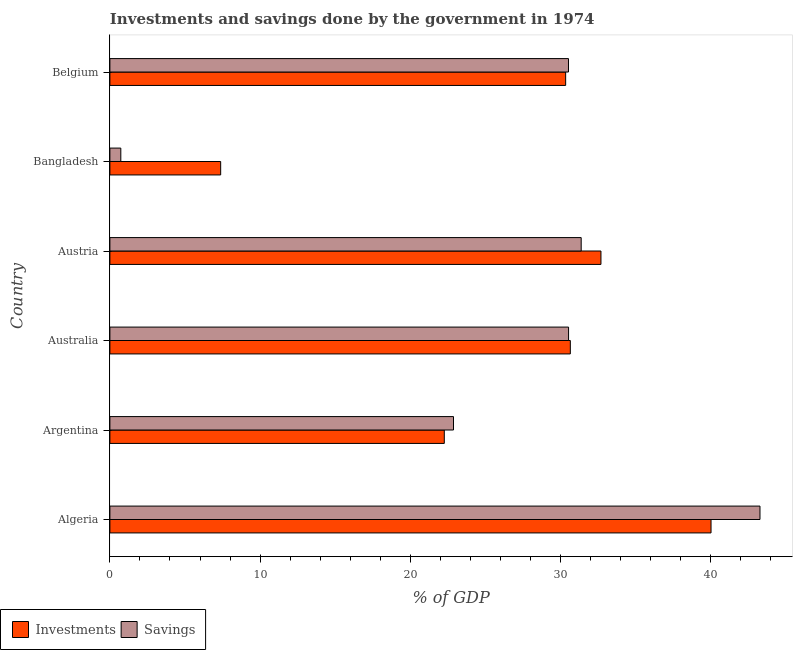How many different coloured bars are there?
Your response must be concise. 2. Are the number of bars on each tick of the Y-axis equal?
Make the answer very short. Yes. How many bars are there on the 3rd tick from the top?
Your answer should be compact. 2. How many bars are there on the 5th tick from the bottom?
Your answer should be very brief. 2. What is the label of the 2nd group of bars from the top?
Provide a short and direct response. Bangladesh. In how many cases, is the number of bars for a given country not equal to the number of legend labels?
Provide a succinct answer. 0. What is the investments of government in Australia?
Your answer should be very brief. 30.65. Across all countries, what is the maximum investments of government?
Your response must be concise. 40.02. Across all countries, what is the minimum investments of government?
Ensure brevity in your answer.  7.37. In which country was the savings of government maximum?
Keep it short and to the point. Algeria. In which country was the investments of government minimum?
Keep it short and to the point. Bangladesh. What is the total investments of government in the graph?
Your answer should be compact. 163.33. What is the difference between the savings of government in Austria and that in Bangladesh?
Provide a succinct answer. 30.65. What is the difference between the investments of government in Australia and the savings of government in Austria?
Offer a terse response. -0.72. What is the average investments of government per country?
Give a very brief answer. 27.22. What is the difference between the investments of government and savings of government in Argentina?
Make the answer very short. -0.61. What is the ratio of the savings of government in Algeria to that in Australia?
Your answer should be very brief. 1.42. What is the difference between the highest and the second highest savings of government?
Ensure brevity in your answer.  11.9. What is the difference between the highest and the lowest savings of government?
Offer a terse response. 42.55. Is the sum of the savings of government in Australia and Belgium greater than the maximum investments of government across all countries?
Offer a very short reply. Yes. What does the 2nd bar from the top in Argentina represents?
Ensure brevity in your answer.  Investments. What does the 2nd bar from the bottom in Australia represents?
Make the answer very short. Savings. Are the values on the major ticks of X-axis written in scientific E-notation?
Your answer should be very brief. No. Where does the legend appear in the graph?
Your answer should be compact. Bottom left. How are the legend labels stacked?
Offer a terse response. Horizontal. What is the title of the graph?
Make the answer very short. Investments and savings done by the government in 1974. Does "Nitrous oxide" appear as one of the legend labels in the graph?
Make the answer very short. No. What is the label or title of the X-axis?
Your response must be concise. % of GDP. What is the % of GDP in Investments in Algeria?
Provide a short and direct response. 40.02. What is the % of GDP in Savings in Algeria?
Provide a succinct answer. 43.28. What is the % of GDP in Investments in Argentina?
Give a very brief answer. 22.26. What is the % of GDP of Savings in Argentina?
Provide a succinct answer. 22.87. What is the % of GDP in Investments in Australia?
Offer a terse response. 30.65. What is the % of GDP of Savings in Australia?
Your answer should be compact. 30.53. What is the % of GDP of Investments in Austria?
Offer a terse response. 32.69. What is the % of GDP of Savings in Austria?
Your answer should be compact. 31.37. What is the % of GDP in Investments in Bangladesh?
Offer a very short reply. 7.37. What is the % of GDP in Savings in Bangladesh?
Make the answer very short. 0.73. What is the % of GDP of Investments in Belgium?
Provide a succinct answer. 30.34. What is the % of GDP of Savings in Belgium?
Offer a very short reply. 30.53. Across all countries, what is the maximum % of GDP in Investments?
Give a very brief answer. 40.02. Across all countries, what is the maximum % of GDP of Savings?
Offer a terse response. 43.28. Across all countries, what is the minimum % of GDP in Investments?
Keep it short and to the point. 7.37. Across all countries, what is the minimum % of GDP of Savings?
Make the answer very short. 0.73. What is the total % of GDP of Investments in the graph?
Ensure brevity in your answer.  163.33. What is the total % of GDP of Savings in the graph?
Make the answer very short. 159.31. What is the difference between the % of GDP in Investments in Algeria and that in Argentina?
Give a very brief answer. 17.76. What is the difference between the % of GDP in Savings in Algeria and that in Argentina?
Make the answer very short. 20.4. What is the difference between the % of GDP of Investments in Algeria and that in Australia?
Provide a succinct answer. 9.37. What is the difference between the % of GDP of Savings in Algeria and that in Australia?
Provide a succinct answer. 12.74. What is the difference between the % of GDP of Investments in Algeria and that in Austria?
Offer a terse response. 7.33. What is the difference between the % of GDP in Savings in Algeria and that in Austria?
Give a very brief answer. 11.9. What is the difference between the % of GDP in Investments in Algeria and that in Bangladesh?
Provide a short and direct response. 32.64. What is the difference between the % of GDP in Savings in Algeria and that in Bangladesh?
Your answer should be compact. 42.55. What is the difference between the % of GDP in Investments in Algeria and that in Belgium?
Your response must be concise. 9.68. What is the difference between the % of GDP in Savings in Algeria and that in Belgium?
Your response must be concise. 12.75. What is the difference between the % of GDP of Investments in Argentina and that in Australia?
Give a very brief answer. -8.39. What is the difference between the % of GDP of Savings in Argentina and that in Australia?
Keep it short and to the point. -7.66. What is the difference between the % of GDP in Investments in Argentina and that in Austria?
Give a very brief answer. -10.43. What is the difference between the % of GDP of Savings in Argentina and that in Austria?
Give a very brief answer. -8.5. What is the difference between the % of GDP in Investments in Argentina and that in Bangladesh?
Give a very brief answer. 14.89. What is the difference between the % of GDP of Savings in Argentina and that in Bangladesh?
Offer a very short reply. 22.15. What is the difference between the % of GDP in Investments in Argentina and that in Belgium?
Offer a very short reply. -8.08. What is the difference between the % of GDP in Savings in Argentina and that in Belgium?
Your answer should be compact. -7.65. What is the difference between the % of GDP in Investments in Australia and that in Austria?
Give a very brief answer. -2.04. What is the difference between the % of GDP of Savings in Australia and that in Austria?
Keep it short and to the point. -0.84. What is the difference between the % of GDP of Investments in Australia and that in Bangladesh?
Your answer should be compact. 23.28. What is the difference between the % of GDP in Savings in Australia and that in Bangladesh?
Keep it short and to the point. 29.81. What is the difference between the % of GDP in Investments in Australia and that in Belgium?
Give a very brief answer. 0.31. What is the difference between the % of GDP of Savings in Australia and that in Belgium?
Offer a terse response. 0. What is the difference between the % of GDP of Investments in Austria and that in Bangladesh?
Make the answer very short. 25.31. What is the difference between the % of GDP of Savings in Austria and that in Bangladesh?
Make the answer very short. 30.65. What is the difference between the % of GDP in Investments in Austria and that in Belgium?
Give a very brief answer. 2.35. What is the difference between the % of GDP in Savings in Austria and that in Belgium?
Give a very brief answer. 0.85. What is the difference between the % of GDP in Investments in Bangladesh and that in Belgium?
Your answer should be very brief. -22.96. What is the difference between the % of GDP in Savings in Bangladesh and that in Belgium?
Your response must be concise. -29.8. What is the difference between the % of GDP of Investments in Algeria and the % of GDP of Savings in Argentina?
Ensure brevity in your answer.  17.14. What is the difference between the % of GDP of Investments in Algeria and the % of GDP of Savings in Australia?
Your answer should be compact. 9.48. What is the difference between the % of GDP of Investments in Algeria and the % of GDP of Savings in Austria?
Offer a very short reply. 8.64. What is the difference between the % of GDP of Investments in Algeria and the % of GDP of Savings in Bangladesh?
Offer a very short reply. 39.29. What is the difference between the % of GDP of Investments in Algeria and the % of GDP of Savings in Belgium?
Your answer should be compact. 9.49. What is the difference between the % of GDP of Investments in Argentina and the % of GDP of Savings in Australia?
Keep it short and to the point. -8.27. What is the difference between the % of GDP of Investments in Argentina and the % of GDP of Savings in Austria?
Ensure brevity in your answer.  -9.11. What is the difference between the % of GDP in Investments in Argentina and the % of GDP in Savings in Bangladesh?
Ensure brevity in your answer.  21.53. What is the difference between the % of GDP of Investments in Argentina and the % of GDP of Savings in Belgium?
Ensure brevity in your answer.  -8.27. What is the difference between the % of GDP in Investments in Australia and the % of GDP in Savings in Austria?
Make the answer very short. -0.72. What is the difference between the % of GDP of Investments in Australia and the % of GDP of Savings in Bangladesh?
Make the answer very short. 29.92. What is the difference between the % of GDP in Investments in Australia and the % of GDP in Savings in Belgium?
Ensure brevity in your answer.  0.12. What is the difference between the % of GDP in Investments in Austria and the % of GDP in Savings in Bangladesh?
Provide a short and direct response. 31.96. What is the difference between the % of GDP in Investments in Austria and the % of GDP in Savings in Belgium?
Offer a terse response. 2.16. What is the difference between the % of GDP of Investments in Bangladesh and the % of GDP of Savings in Belgium?
Give a very brief answer. -23.15. What is the average % of GDP in Investments per country?
Keep it short and to the point. 27.22. What is the average % of GDP of Savings per country?
Make the answer very short. 26.55. What is the difference between the % of GDP in Investments and % of GDP in Savings in Algeria?
Offer a terse response. -3.26. What is the difference between the % of GDP in Investments and % of GDP in Savings in Argentina?
Ensure brevity in your answer.  -0.61. What is the difference between the % of GDP of Investments and % of GDP of Savings in Australia?
Provide a succinct answer. 0.12. What is the difference between the % of GDP of Investments and % of GDP of Savings in Austria?
Provide a short and direct response. 1.32. What is the difference between the % of GDP in Investments and % of GDP in Savings in Bangladesh?
Provide a short and direct response. 6.65. What is the difference between the % of GDP in Investments and % of GDP in Savings in Belgium?
Your answer should be compact. -0.19. What is the ratio of the % of GDP of Investments in Algeria to that in Argentina?
Keep it short and to the point. 1.8. What is the ratio of the % of GDP of Savings in Algeria to that in Argentina?
Make the answer very short. 1.89. What is the ratio of the % of GDP of Investments in Algeria to that in Australia?
Offer a very short reply. 1.31. What is the ratio of the % of GDP in Savings in Algeria to that in Australia?
Ensure brevity in your answer.  1.42. What is the ratio of the % of GDP of Investments in Algeria to that in Austria?
Your response must be concise. 1.22. What is the ratio of the % of GDP of Savings in Algeria to that in Austria?
Your answer should be very brief. 1.38. What is the ratio of the % of GDP in Investments in Algeria to that in Bangladesh?
Give a very brief answer. 5.43. What is the ratio of the % of GDP in Savings in Algeria to that in Bangladesh?
Ensure brevity in your answer.  59.49. What is the ratio of the % of GDP in Investments in Algeria to that in Belgium?
Make the answer very short. 1.32. What is the ratio of the % of GDP of Savings in Algeria to that in Belgium?
Provide a succinct answer. 1.42. What is the ratio of the % of GDP of Investments in Argentina to that in Australia?
Ensure brevity in your answer.  0.73. What is the ratio of the % of GDP of Savings in Argentina to that in Australia?
Your response must be concise. 0.75. What is the ratio of the % of GDP of Investments in Argentina to that in Austria?
Ensure brevity in your answer.  0.68. What is the ratio of the % of GDP in Savings in Argentina to that in Austria?
Your answer should be very brief. 0.73. What is the ratio of the % of GDP of Investments in Argentina to that in Bangladesh?
Give a very brief answer. 3.02. What is the ratio of the % of GDP of Savings in Argentina to that in Bangladesh?
Keep it short and to the point. 31.45. What is the ratio of the % of GDP of Investments in Argentina to that in Belgium?
Your answer should be very brief. 0.73. What is the ratio of the % of GDP of Savings in Argentina to that in Belgium?
Your answer should be very brief. 0.75. What is the ratio of the % of GDP of Investments in Australia to that in Austria?
Keep it short and to the point. 0.94. What is the ratio of the % of GDP of Savings in Australia to that in Austria?
Offer a very short reply. 0.97. What is the ratio of the % of GDP of Investments in Australia to that in Bangladesh?
Your answer should be compact. 4.16. What is the ratio of the % of GDP in Savings in Australia to that in Bangladesh?
Give a very brief answer. 41.98. What is the ratio of the % of GDP of Investments in Australia to that in Belgium?
Provide a short and direct response. 1.01. What is the ratio of the % of GDP in Savings in Australia to that in Belgium?
Ensure brevity in your answer.  1. What is the ratio of the % of GDP of Investments in Austria to that in Bangladesh?
Keep it short and to the point. 4.43. What is the ratio of the % of GDP of Savings in Austria to that in Bangladesh?
Keep it short and to the point. 43.13. What is the ratio of the % of GDP of Investments in Austria to that in Belgium?
Keep it short and to the point. 1.08. What is the ratio of the % of GDP in Savings in Austria to that in Belgium?
Offer a terse response. 1.03. What is the ratio of the % of GDP of Investments in Bangladesh to that in Belgium?
Ensure brevity in your answer.  0.24. What is the ratio of the % of GDP of Savings in Bangladesh to that in Belgium?
Keep it short and to the point. 0.02. What is the difference between the highest and the second highest % of GDP in Investments?
Provide a short and direct response. 7.33. What is the difference between the highest and the second highest % of GDP of Savings?
Your answer should be very brief. 11.9. What is the difference between the highest and the lowest % of GDP in Investments?
Offer a very short reply. 32.64. What is the difference between the highest and the lowest % of GDP in Savings?
Provide a short and direct response. 42.55. 